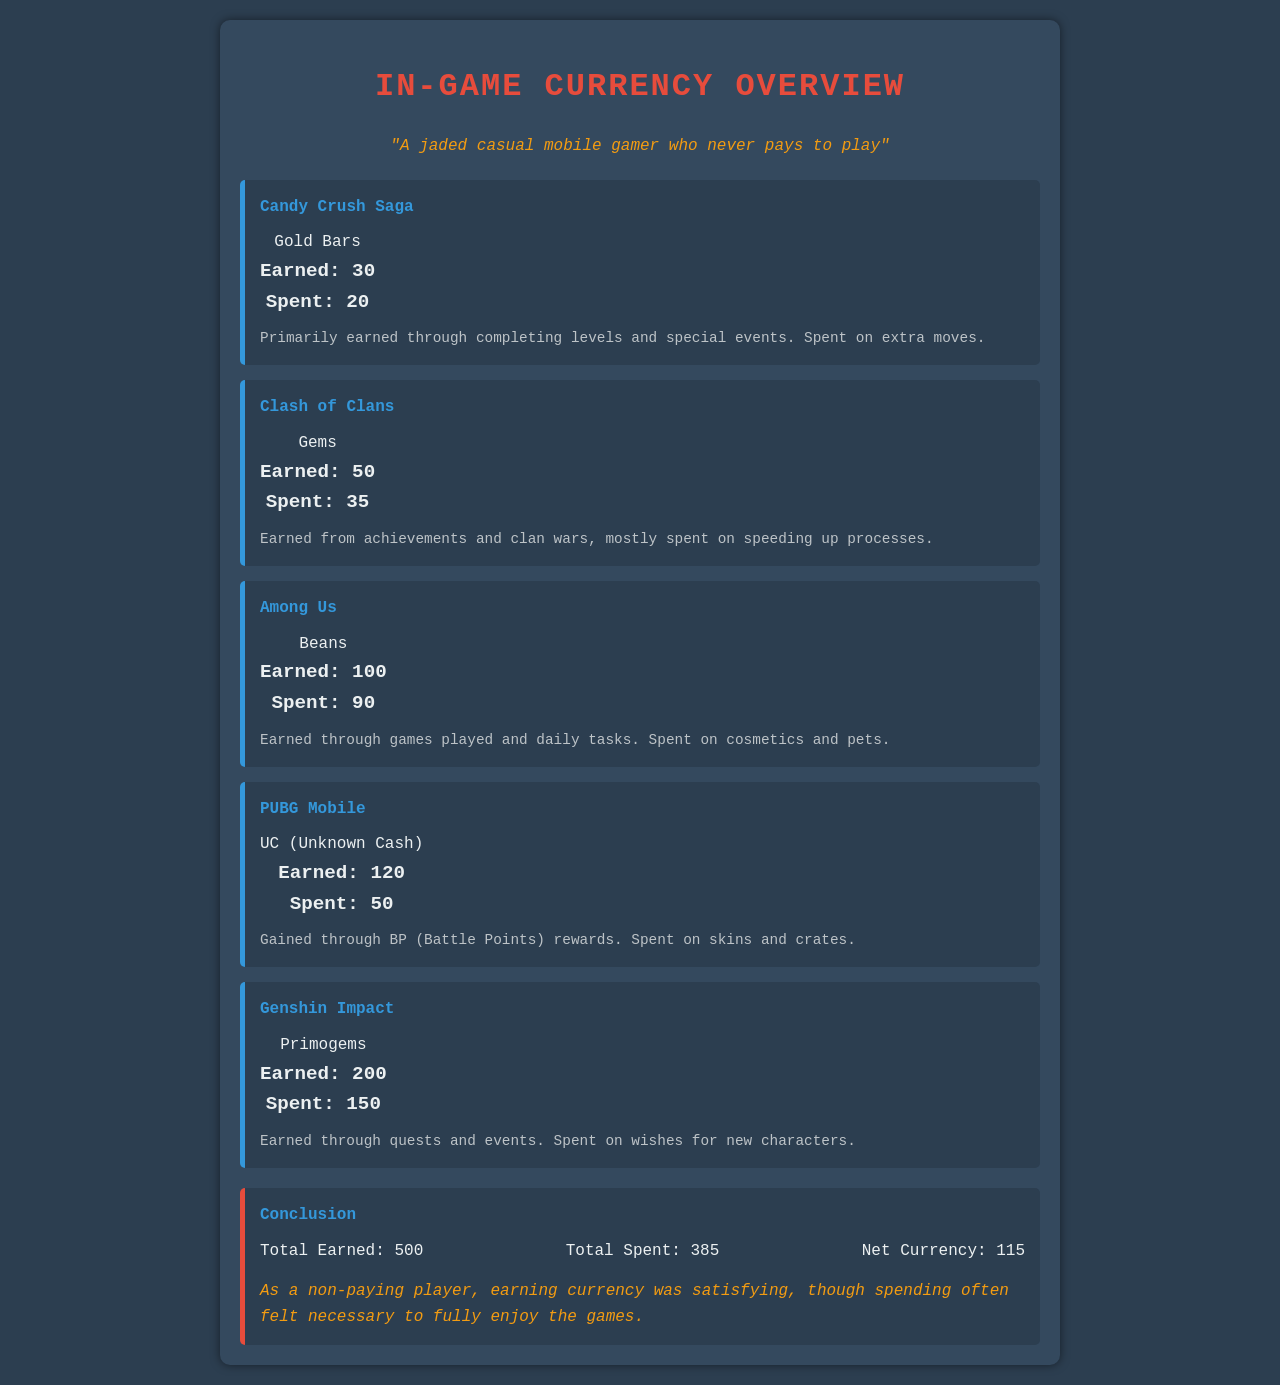What is the total earned currency? The total earned currency is the sum of all earned values from each game, which is 30 + 50 + 100 + 120 + 200 = 500.
Answer: 500 What is the total spent currency? The total spent currency is the sum of all spent values from each game, which is 20 + 35 + 90 + 50 + 150 = 385.
Answer: 385 What is the net currency? The net currency is calculated by subtracting the total spent from the total earned, which is 500 - 385 = 115.
Answer: 115 How many Gold Bars were earned in Candy Crush Saga? The document states that 30 Gold Bars were earned in Candy Crush Saga.
Answer: 30 What currency is used in PUBG Mobile? The currency used in PUBG Mobile is Unknown Cash (UC).
Answer: UC In which game were Beans earned? Beans were earned in Among Us.
Answer: Among Us What is the primary use of the spent currency in Clash of Clans? The spent currency in Clash of Clans is primarily used for speeding up processes.
Answer: Speeding up processes How many Primogems were spent in Genshin Impact? According to the document, 150 Primogems were spent in Genshin Impact.
Answer: 150 What was the main source of currency in PUBG Mobile? The main source of currency in PUBG Mobile is Battle Points (BP) rewards.
Answer: Battle Points What did the jaded casual mobile gamer reflect about spending currency? The jaded casual mobile gamer reflected that spending often felt necessary to fully enjoy the games.
Answer: Necessary to fully enjoy the games 